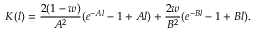<formula> <loc_0><loc_0><loc_500><loc_500>K ( l ) = { \frac { 2 ( 1 - w ) } { A ^ { 2 } } } ( e ^ { - A l } - 1 + A l ) + { \frac { 2 w } { B ^ { 2 } } } ( e ^ { - B l } - 1 + B l ) .</formula> 